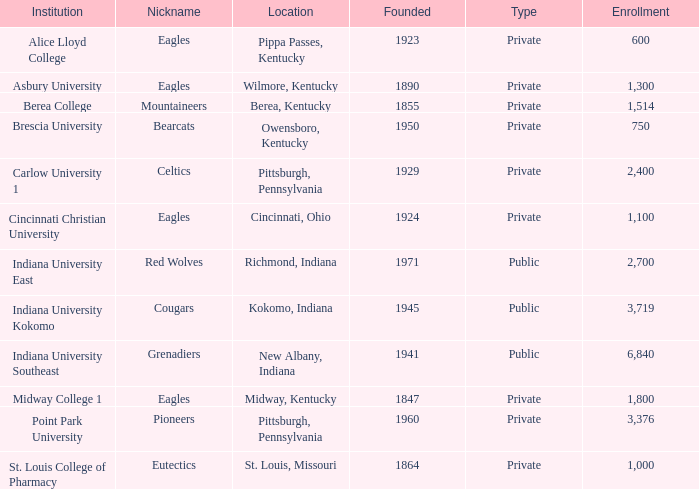Which of the private colleges is the oldest, and whose nickname is the Mountaineers? 1855.0. Parse the full table. {'header': ['Institution', 'Nickname', 'Location', 'Founded', 'Type', 'Enrollment'], 'rows': [['Alice Lloyd College', 'Eagles', 'Pippa Passes, Kentucky', '1923', 'Private', '600'], ['Asbury University', 'Eagles', 'Wilmore, Kentucky', '1890', 'Private', '1,300'], ['Berea College', 'Mountaineers', 'Berea, Kentucky', '1855', 'Private', '1,514'], ['Brescia University', 'Bearcats', 'Owensboro, Kentucky', '1950', 'Private', '750'], ['Carlow University 1', 'Celtics', 'Pittsburgh, Pennsylvania', '1929', 'Private', '2,400'], ['Cincinnati Christian University', 'Eagles', 'Cincinnati, Ohio', '1924', 'Private', '1,100'], ['Indiana University East', 'Red Wolves', 'Richmond, Indiana', '1971', 'Public', '2,700'], ['Indiana University Kokomo', 'Cougars', 'Kokomo, Indiana', '1945', 'Public', '3,719'], ['Indiana University Southeast', 'Grenadiers', 'New Albany, Indiana', '1941', 'Public', '6,840'], ['Midway College 1', 'Eagles', 'Midway, Kentucky', '1847', 'Private', '1,800'], ['Point Park University', 'Pioneers', 'Pittsburgh, Pennsylvania', '1960', 'Private', '3,376'], ['St. Louis College of Pharmacy', 'Eutectics', 'St. Louis, Missouri', '1864', 'Private', '1,000']]} 